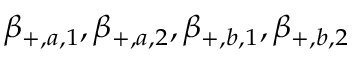Convert formula to latex. <formula><loc_0><loc_0><loc_500><loc_500>\beta _ { + , a , 1 } , \beta _ { + , a , 2 } , \beta _ { + , b , 1 } , \beta _ { + , b , 2 }</formula> 